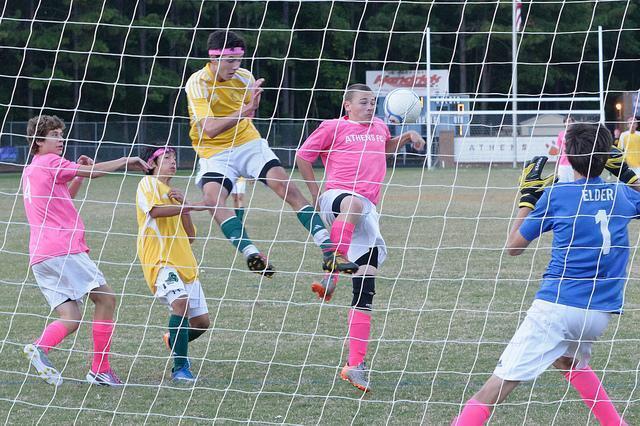How many people are visible?
Give a very brief answer. 5. How many horses are on the picture?
Give a very brief answer. 0. 